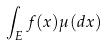<formula> <loc_0><loc_0><loc_500><loc_500>\int _ { E } f ( x ) \mu ( d x )</formula> 